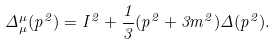<formula> <loc_0><loc_0><loc_500><loc_500>\Delta _ { \mu } ^ { \mu } ( p ^ { 2 } ) = I ^ { 2 } + \frac { 1 } { 3 } ( p ^ { 2 } + 3 m ^ { 2 } ) \Delta ( p ^ { 2 } ) .</formula> 